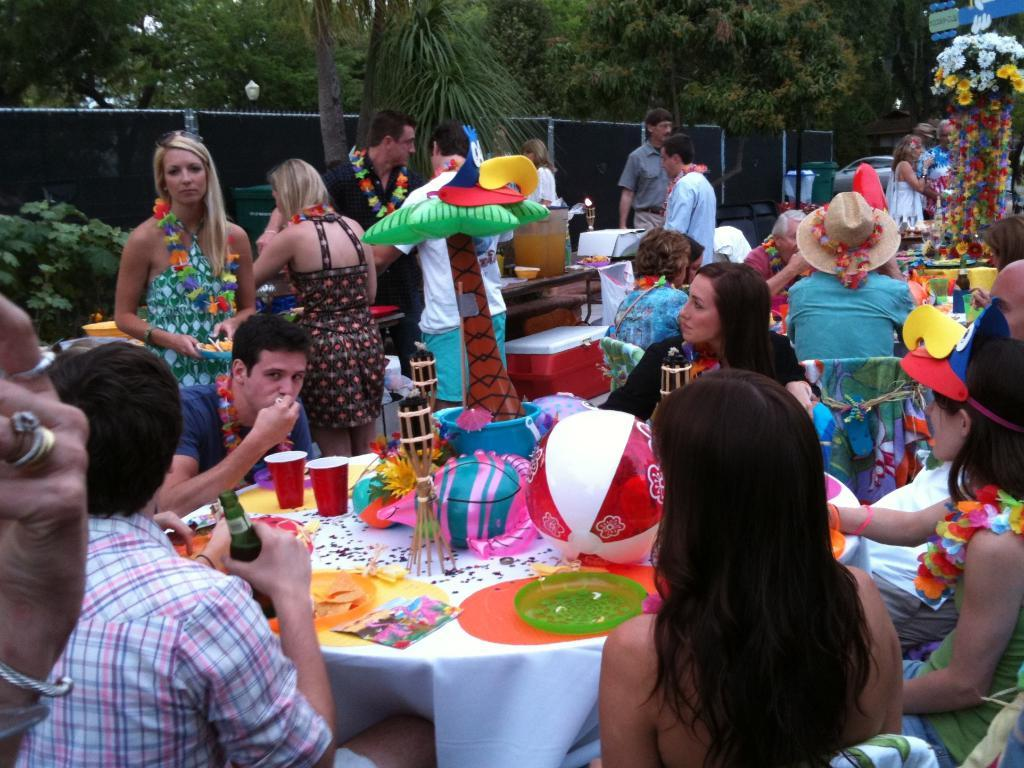How many people are in the image? There are many people in the image. What are some of the people doing in the image? Some people are sitting, drinking, eating, and standing. What can be seen in the background of the image? There are trees in the image. What type of sponge can be heard making a voice in the image? There is no sponge or voice present in the image. How is the power being generated in the image? There is no reference to power generation in the image. 